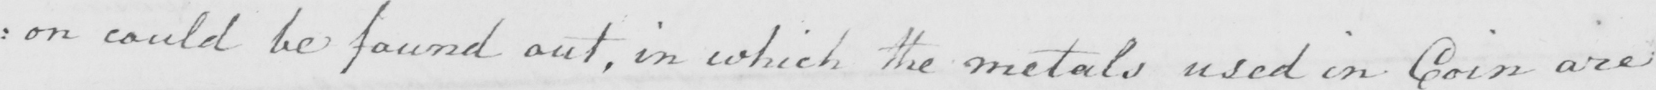What text is written in this handwritten line? : on could be found out , in which the metals used in Coin are 